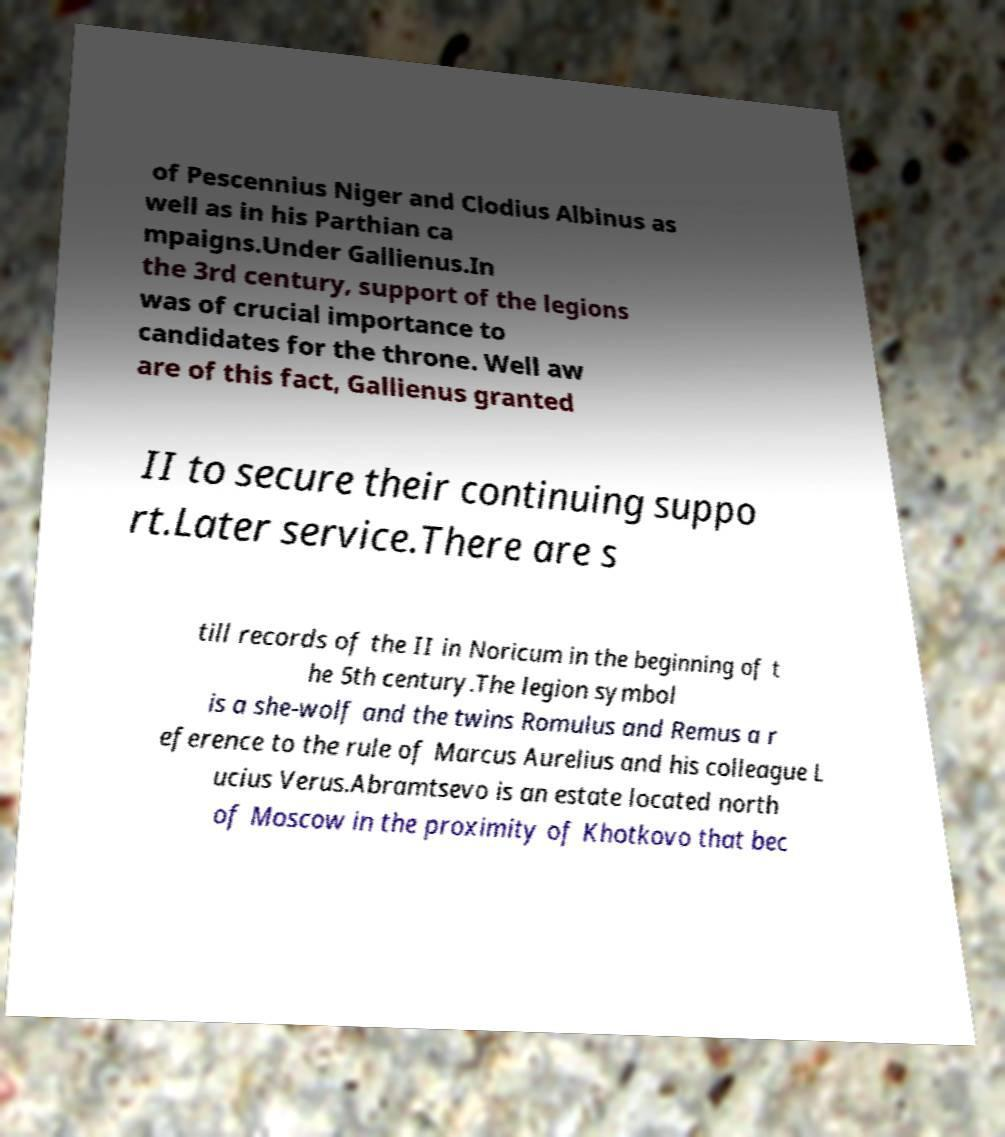Could you extract and type out the text from this image? of Pescennius Niger and Clodius Albinus as well as in his Parthian ca mpaigns.Under Gallienus.In the 3rd century, support of the legions was of crucial importance to candidates for the throne. Well aw are of this fact, Gallienus granted II to secure their continuing suppo rt.Later service.There are s till records of the II in Noricum in the beginning of t he 5th century.The legion symbol is a she-wolf and the twins Romulus and Remus a r eference to the rule of Marcus Aurelius and his colleague L ucius Verus.Abramtsevo is an estate located north of Moscow in the proximity of Khotkovo that bec 